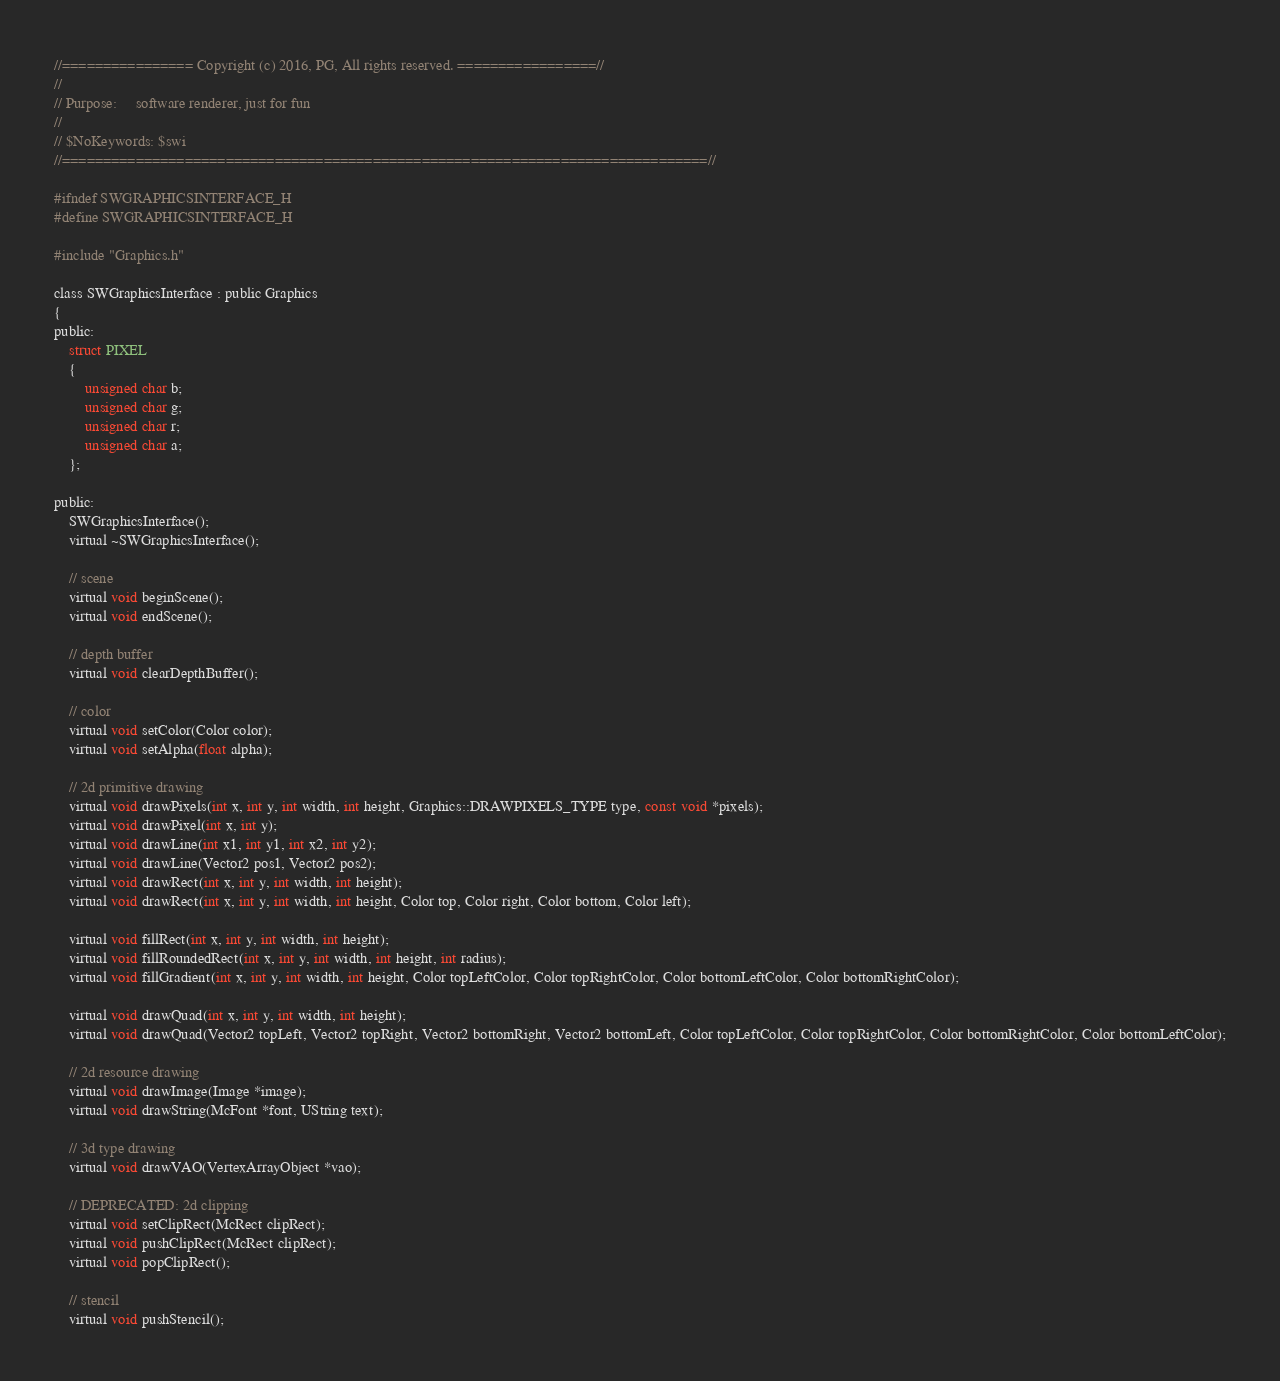Convert code to text. <code><loc_0><loc_0><loc_500><loc_500><_C_>//================ Copyright (c) 2016, PG, All rights reserved. =================//
//
// Purpose:		software renderer, just for fun
//
// $NoKeywords: $swi
//===============================================================================//

#ifndef SWGRAPHICSINTERFACE_H
#define SWGRAPHICSINTERFACE_H

#include "Graphics.h"

class SWGraphicsInterface : public Graphics
{
public:
	struct PIXEL
	{
		unsigned char b;
		unsigned char g;
		unsigned char r;
		unsigned char a;
	};

public:
	SWGraphicsInterface();
	virtual ~SWGraphicsInterface();

	// scene
	virtual void beginScene();
	virtual void endScene();

	// depth buffer
	virtual void clearDepthBuffer();

	// color
	virtual void setColor(Color color);
	virtual void setAlpha(float alpha);

	// 2d primitive drawing
	virtual void drawPixels(int x, int y, int width, int height, Graphics::DRAWPIXELS_TYPE type, const void *pixels);
	virtual void drawPixel(int x, int y);
	virtual void drawLine(int x1, int y1, int x2, int y2);
	virtual void drawLine(Vector2 pos1, Vector2 pos2);
	virtual void drawRect(int x, int y, int width, int height);
	virtual void drawRect(int x, int y, int width, int height, Color top, Color right, Color bottom, Color left);

	virtual void fillRect(int x, int y, int width, int height);
	virtual void fillRoundedRect(int x, int y, int width, int height, int radius);
	virtual void fillGradient(int x, int y, int width, int height, Color topLeftColor, Color topRightColor, Color bottomLeftColor, Color bottomRightColor);

	virtual void drawQuad(int x, int y, int width, int height);
	virtual void drawQuad(Vector2 topLeft, Vector2 topRight, Vector2 bottomRight, Vector2 bottomLeft, Color topLeftColor, Color topRightColor, Color bottomRightColor, Color bottomLeftColor);

	// 2d resource drawing
	virtual void drawImage(Image *image);
	virtual void drawString(McFont *font, UString text);

	// 3d type drawing
	virtual void drawVAO(VertexArrayObject *vao);

	// DEPRECATED: 2d clipping
	virtual void setClipRect(McRect clipRect);
	virtual void pushClipRect(McRect clipRect);
	virtual void popClipRect();

	// stencil
	virtual void pushStencil();</code> 